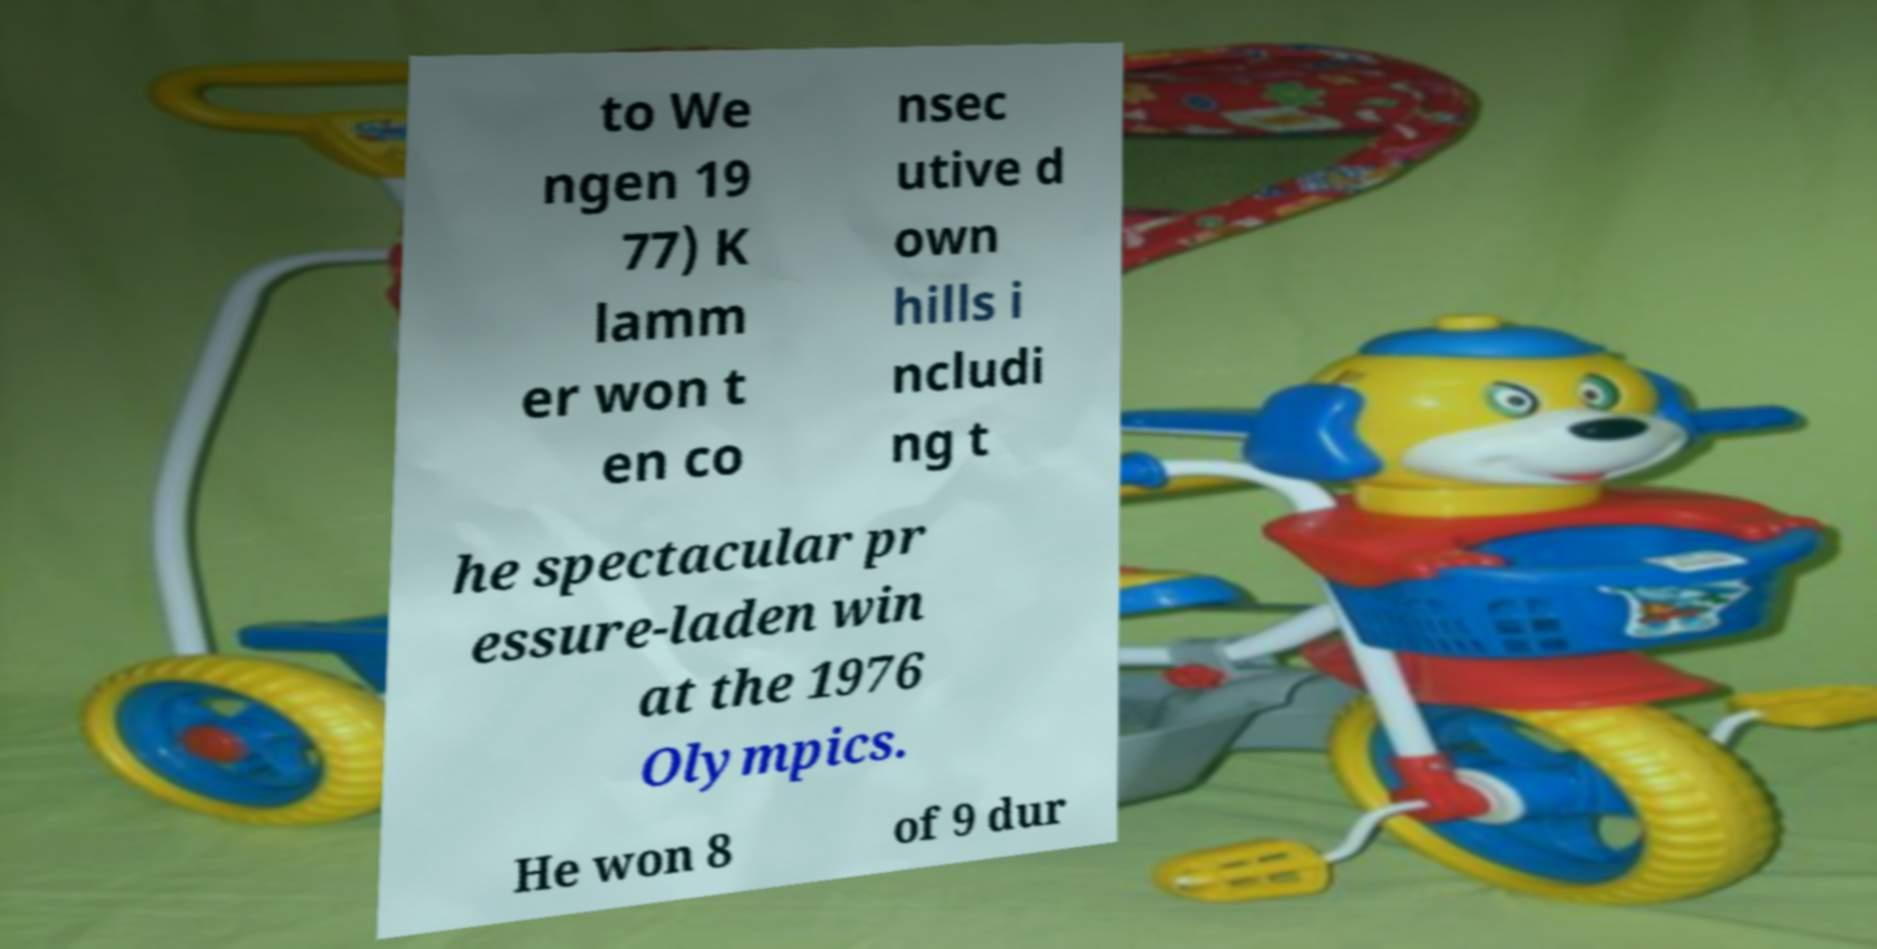Please read and relay the text visible in this image. What does it say? to We ngen 19 77) K lamm er won t en co nsec utive d own hills i ncludi ng t he spectacular pr essure-laden win at the 1976 Olympics. He won 8 of 9 dur 